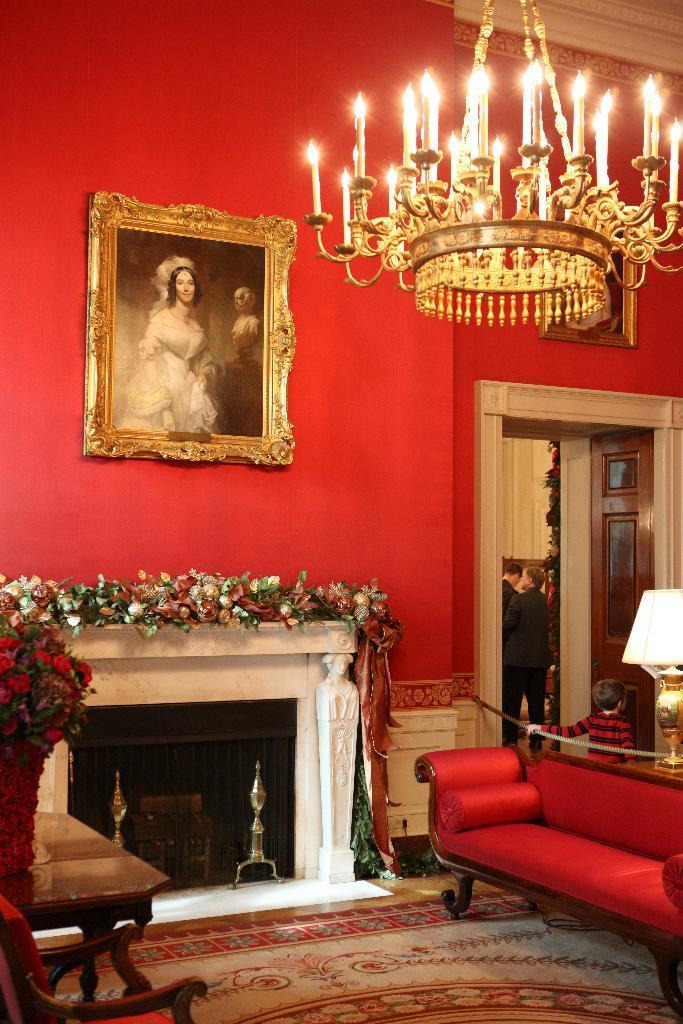In one or two sentences, can you explain what this image depicts? A picture inside of a room. This is couch. A picture of a woman on red color wall. These are candles. For the persons are standing. These are flowers. 